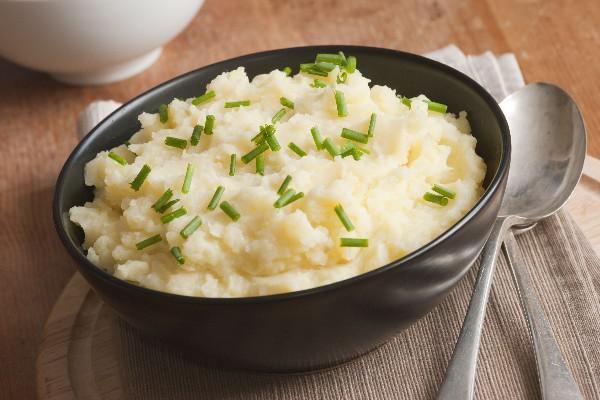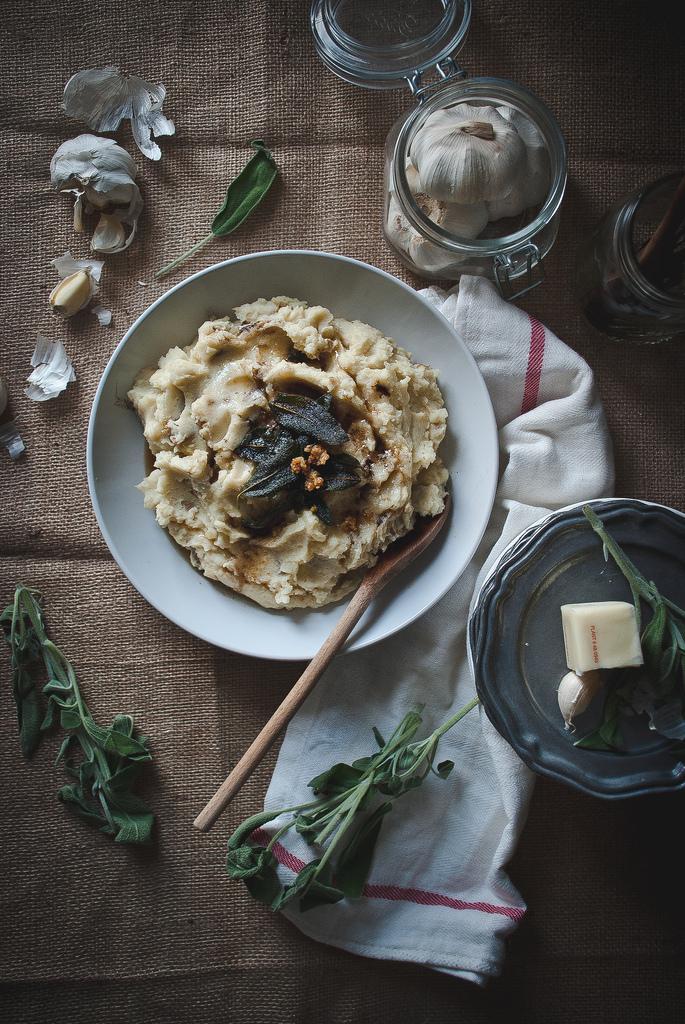The first image is the image on the left, the second image is the image on the right. Examine the images to the left and right. Is the description "The mashed potatoes on the right have a spoon handle visibly sticking out of them" accurate? Answer yes or no. Yes. 